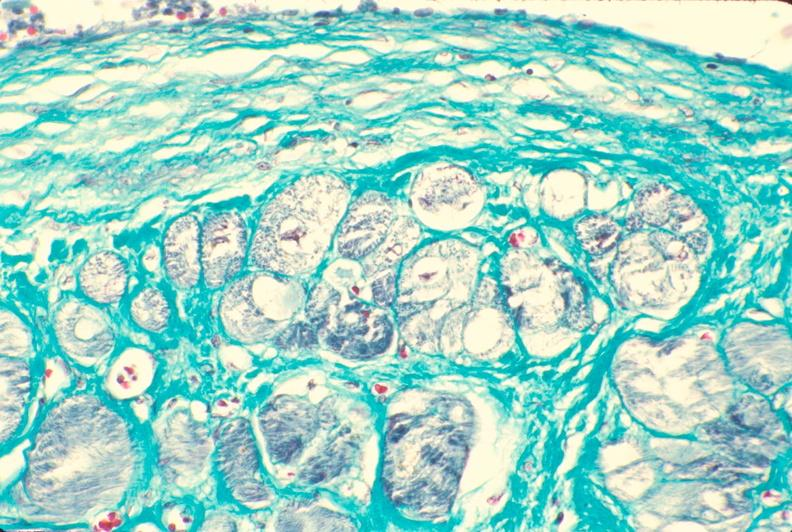s amyloidosis present?
Answer the question using a single word or phrase. No 